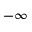Convert formula to latex. <formula><loc_0><loc_0><loc_500><loc_500>- \infty</formula> 